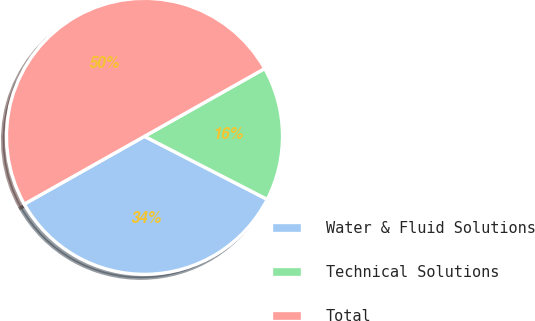Convert chart to OTSL. <chart><loc_0><loc_0><loc_500><loc_500><pie_chart><fcel>Water & Fluid Solutions<fcel>Technical Solutions<fcel>Total<nl><fcel>34.28%<fcel>15.72%<fcel>50.0%<nl></chart> 